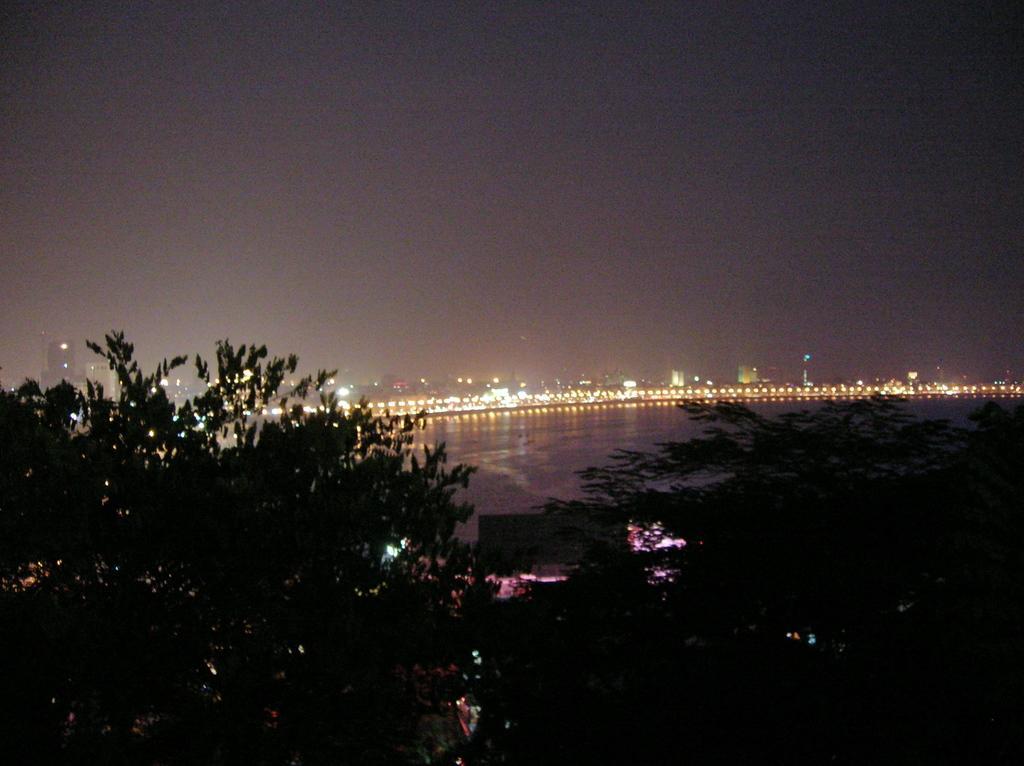Describe this image in one or two sentences. This is an image clicked in the dark. At the bottom there are few trees. In the middle of the image, I can see the water. In the background there are many buildings and lights. At the top of the image I can see the sky. 